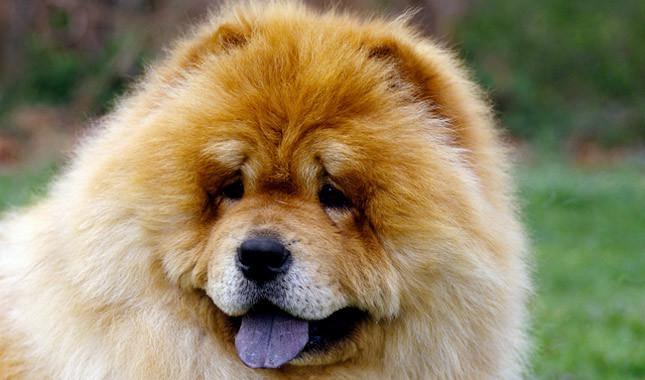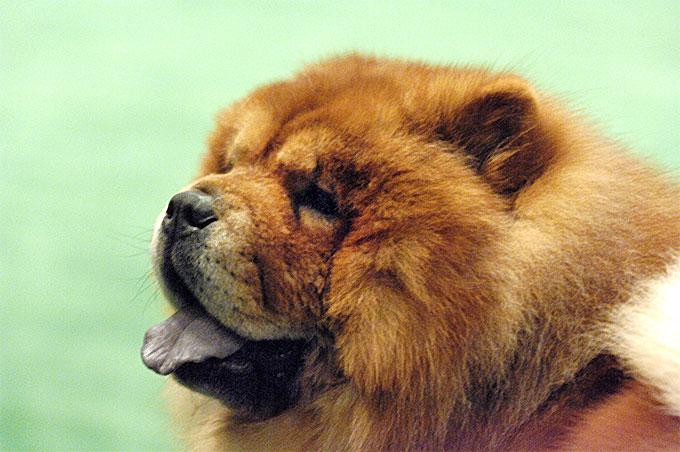The first image is the image on the left, the second image is the image on the right. Given the left and right images, does the statement "All images show exactly one chow dog standing on all fours." hold true? Answer yes or no. No. The first image is the image on the left, the second image is the image on the right. Examine the images to the left and right. Is the description "The dog in the image on the right is standing on all fours in the grass." accurate? Answer yes or no. No. 